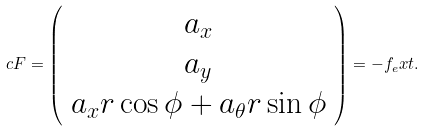Convert formula to latex. <formula><loc_0><loc_0><loc_500><loc_500>c F = \left ( \begin{array} c a _ { x } \\ a _ { y } \\ a _ { x } r \cos \phi + a _ { \theta } r \sin \phi \end{array} \right ) = - f _ { e } x t .</formula> 